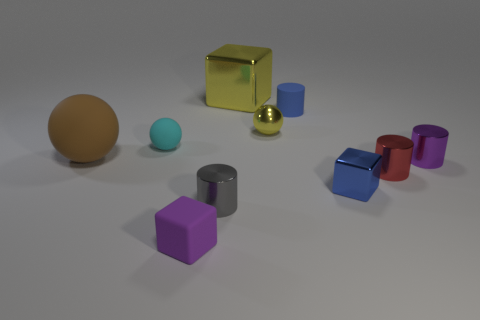What material is the tiny blue thing that is behind the purple object behind the blue object that is in front of the small blue matte object?
Provide a short and direct response. Rubber. There is a block behind the large brown rubber thing; does it have the same color as the matte cylinder?
Provide a short and direct response. No. There is a block that is both behind the gray cylinder and in front of the big brown object; what is its material?
Keep it short and to the point. Metal. Are there any blue metal cylinders of the same size as the blue matte cylinder?
Ensure brevity in your answer.  No. How many tiny red objects are there?
Ensure brevity in your answer.  1. What number of blue metal blocks are behind the small matte ball?
Give a very brief answer. 0. Is the blue cube made of the same material as the small red cylinder?
Your response must be concise. Yes. How many blocks are behind the cyan matte thing and to the right of the tiny yellow metal thing?
Keep it short and to the point. 0. What number of other objects are the same color as the big metal thing?
Ensure brevity in your answer.  1. How many red things are either large rubber objects or balls?
Your response must be concise. 0. 